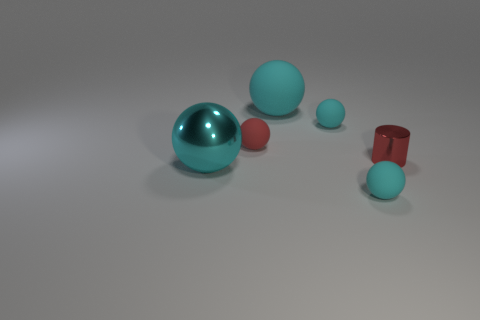Subtract all cyan balls. How many were subtracted if there are2cyan balls left? 2 Subtract all brown blocks. How many cyan spheres are left? 4 Subtract all tiny red rubber balls. How many balls are left? 4 Subtract all red spheres. How many spheres are left? 4 Subtract all gray spheres. Subtract all yellow cylinders. How many spheres are left? 5 Add 3 shiny objects. How many objects exist? 9 Subtract all balls. How many objects are left? 1 Subtract all cyan shiny objects. Subtract all cyan objects. How many objects are left? 1 Add 2 matte spheres. How many matte spheres are left? 6 Add 1 tiny cyan balls. How many tiny cyan balls exist? 3 